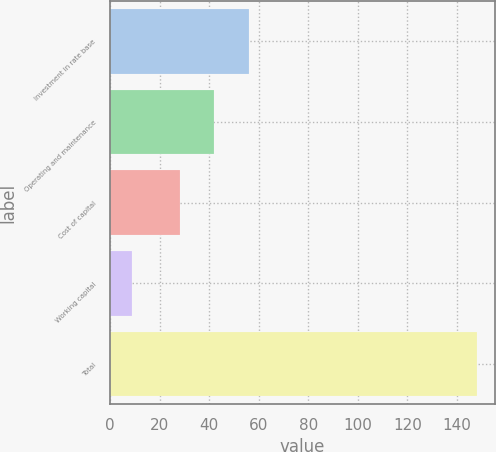Convert chart. <chart><loc_0><loc_0><loc_500><loc_500><bar_chart><fcel>Investment in rate base<fcel>Operating and maintenance<fcel>Cost of capital<fcel>Working capital<fcel>Total<nl><fcel>55.9<fcel>42<fcel>28<fcel>9<fcel>148<nl></chart> 